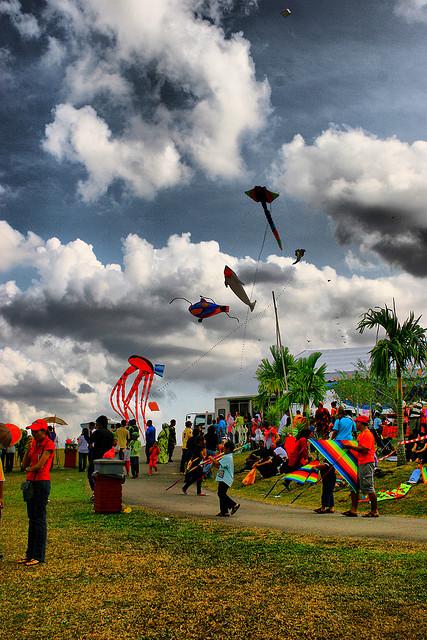How many kites are in the sky?
Keep it brief. 5. Is kite flying fun?
Short answer required. Yes. What clouds are here?
Give a very brief answer. White. What color is the octopus kite?
Keep it brief. Red. 